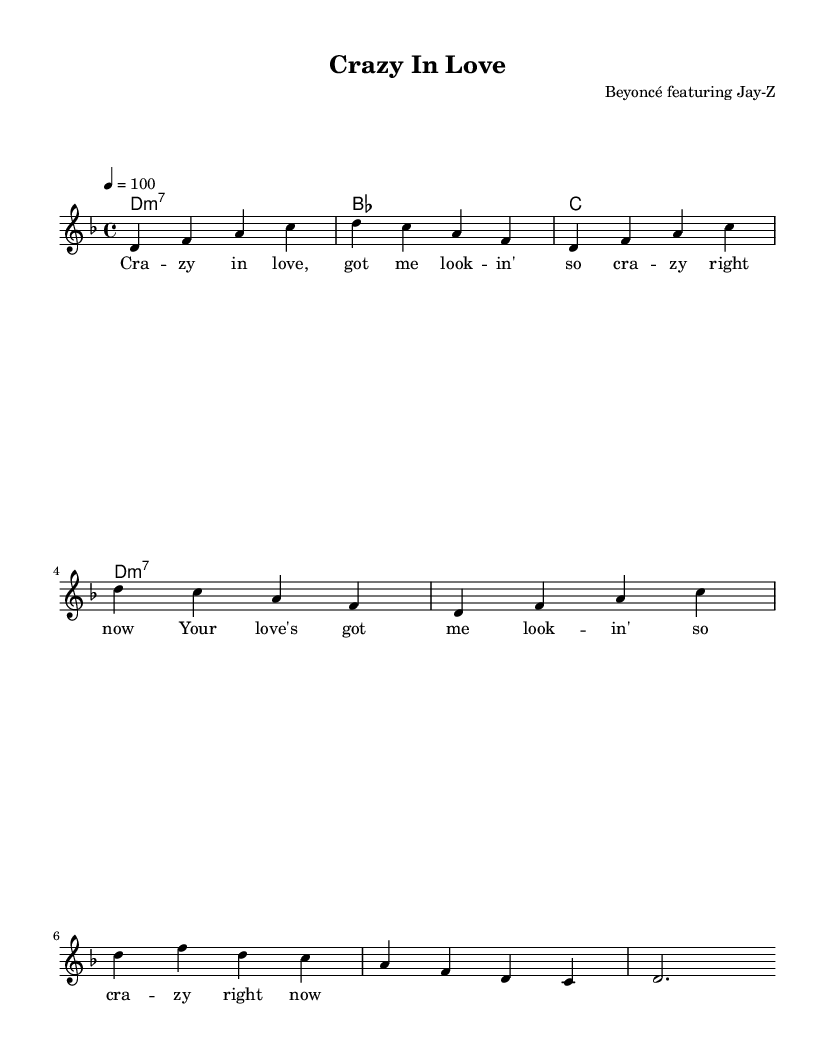What is the key signature of this music? The key signature is indicated at the beginning of the score. It's labeled with one flat, which confirms the key of D minor.
Answer: D minor What is the time signature used in this piece? The time signature is found at the start of the sheet music. It is presented as 4 over 4, indicating a regular meter with four beats per measure.
Answer: 4/4 What is the tempo marking for this piece? The tempo marking is present at the beginning and is marked as quarter note equals 100, indicating the speed of the piece.
Answer: 100 How many measures are in the melody section? To determine this, we count the distinct segments of music between the bar lines in the melody section. There are 8 measures total visible in the provided music.
Answer: 8 What chord is played in the first measure? The first chord is indicated in the chord names section, showing a D minor 7 chord, which is labeled as d1:m7.
Answer: D minor 7 What do the lyrics indicate about the song's theme? The lyrics present in the music mention "crazy in love," which suggests a theme centered on infatuation and emotional intensity typical for upbeat R&B songs.
Answer: Infatuation 